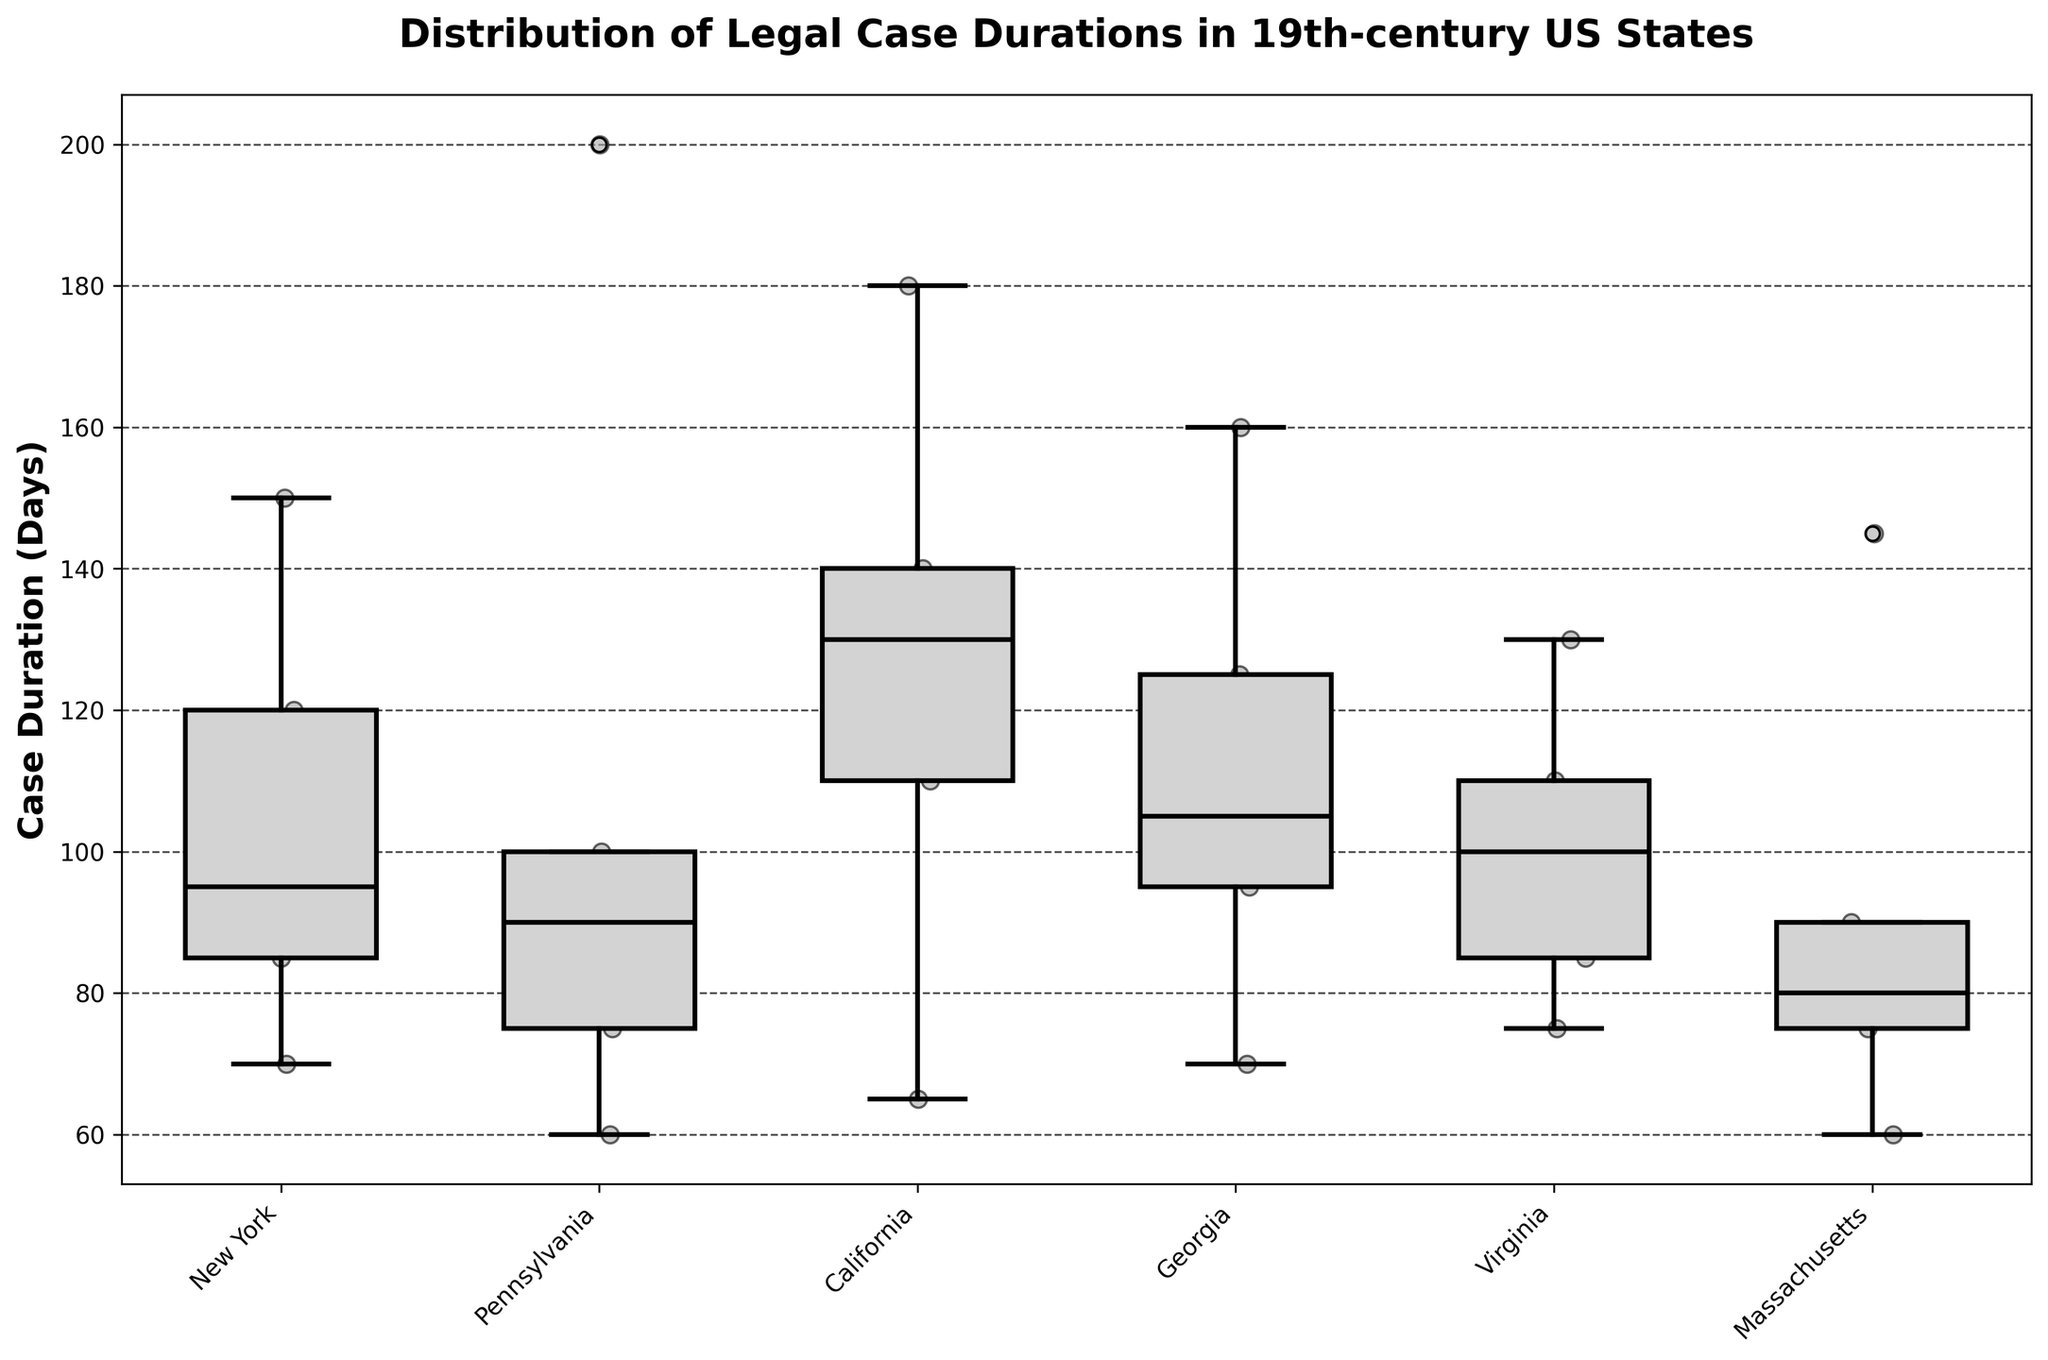What's the title of the figure? The title is displayed at the top of the figure in bold text and provides an overview of what the figure represents. The title here is "Distribution of Legal Case Durations in 19th-century US States".
Answer: Distribution of Legal Case Durations in 19th-century US States Which state has the case with the longest duration? By examining the scatter points in the plot, we can see the highest point appears in Pennsylvania at 200 days, which indicates the case "Penns vs. Baltimore".
Answer: Pennsylvania What is the median case duration in California? The median is the line within the box of the box plot. In California, this line is located at roughly 130 days.
Answer: 130 days Compare the median duration of cases between New York and Virginia. Which state has a higher median duration? By observing the median lines (central line in the box) for both states, New York’s median appears around 95 days while Virginia's median is also around 100 days. This indicates that Virginia’s median duration is higher.
Answer: Virginia Which state has the most dispersed case durations? The dispersion of durations is indicated by the length of the whiskers and the spread of the scatter points. Here, Pennsylvania shows the most dispersed case durations from around 60 to 200 days.
Answer: Pennsylvania Identify the state with the shortest minimum case duration. The minimum case duration for each state appears at the lower whisker end. Massachusetts shows the shortest minimum duration around 60 days.
Answer: Massachusetts How do the case durations in Georgia compare to those in Massachusetts in terms of variability? The variability of case durations is represented by the size of the box and length of the whiskers. Massachusetts has a more compact box and shorter whiskers compared to Georgia, which has a wider box and longer whiskers. Georgia has more variability.
Answer: Georgia has more variability What is the overall trend in case durations among the states shown? Observing the medians, interquartile ranges, and scatter points, most states show a wide range of durations (40 to 200 days). Durations vary broadly without a noticeable overall trend across states.
Answer: No overall trend Between which two states is the difference in the median case duration the largest? Looking at the median lines in each box plot, the largest difference appears between California (around 130 days) and New York (around 95 days), with a difference of approximately 35 days.
Answer: California and New York 